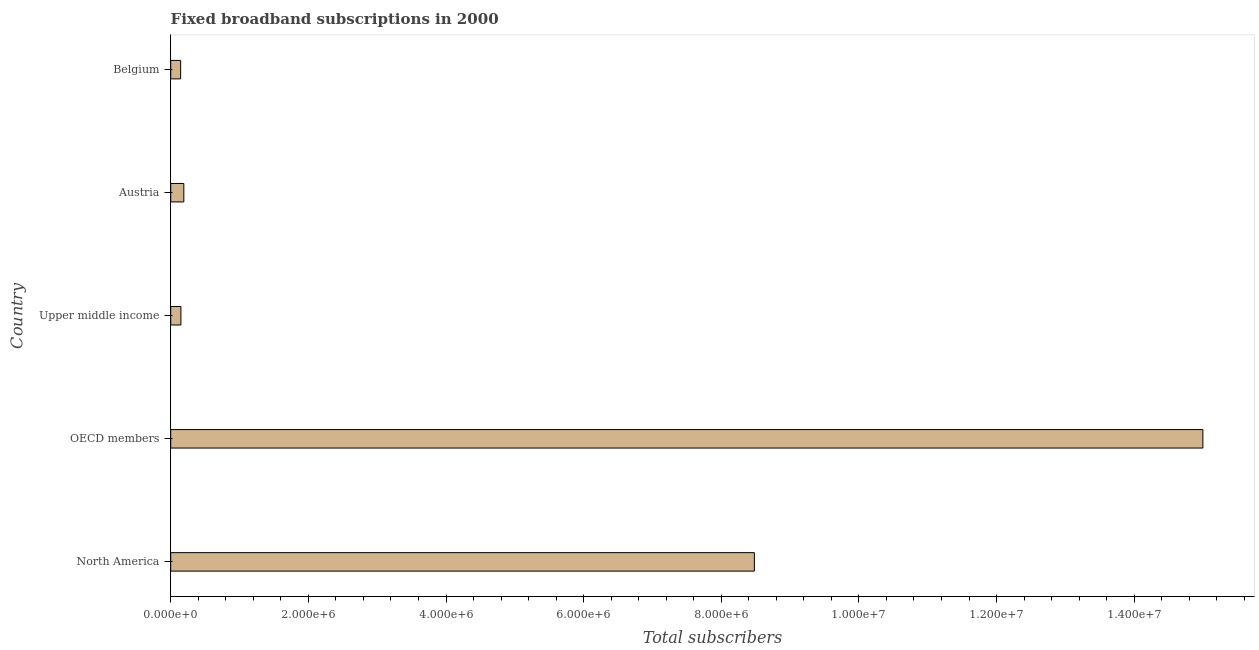What is the title of the graph?
Your response must be concise. Fixed broadband subscriptions in 2000. What is the label or title of the X-axis?
Ensure brevity in your answer.  Total subscribers. What is the label or title of the Y-axis?
Your answer should be very brief. Country. What is the total number of fixed broadband subscriptions in OECD members?
Provide a succinct answer. 1.50e+07. Across all countries, what is the maximum total number of fixed broadband subscriptions?
Keep it short and to the point. 1.50e+07. Across all countries, what is the minimum total number of fixed broadband subscriptions?
Make the answer very short. 1.44e+05. What is the sum of the total number of fixed broadband subscriptions?
Keep it short and to the point. 2.40e+07. What is the difference between the total number of fixed broadband subscriptions in Belgium and Upper middle income?
Offer a very short reply. -3828. What is the average total number of fixed broadband subscriptions per country?
Your answer should be compact. 4.79e+06. What is the median total number of fixed broadband subscriptions?
Make the answer very short. 1.90e+05. What is the difference between the highest and the second highest total number of fixed broadband subscriptions?
Offer a terse response. 6.52e+06. What is the difference between the highest and the lowest total number of fixed broadband subscriptions?
Provide a succinct answer. 1.49e+07. Are all the bars in the graph horizontal?
Keep it short and to the point. Yes. What is the difference between two consecutive major ticks on the X-axis?
Your response must be concise. 2.00e+06. What is the Total subscribers in North America?
Make the answer very short. 8.48e+06. What is the Total subscribers of OECD members?
Make the answer very short. 1.50e+07. What is the Total subscribers in Upper middle income?
Your answer should be compact. 1.48e+05. What is the Total subscribers in Austria?
Keep it short and to the point. 1.90e+05. What is the Total subscribers in Belgium?
Ensure brevity in your answer.  1.44e+05. What is the difference between the Total subscribers in North America and OECD members?
Make the answer very short. -6.52e+06. What is the difference between the Total subscribers in North America and Upper middle income?
Your response must be concise. 8.33e+06. What is the difference between the Total subscribers in North America and Austria?
Make the answer very short. 8.29e+06. What is the difference between the Total subscribers in North America and Belgium?
Keep it short and to the point. 8.34e+06. What is the difference between the Total subscribers in OECD members and Upper middle income?
Provide a short and direct response. 1.48e+07. What is the difference between the Total subscribers in OECD members and Austria?
Your answer should be very brief. 1.48e+07. What is the difference between the Total subscribers in OECD members and Belgium?
Keep it short and to the point. 1.49e+07. What is the difference between the Total subscribers in Upper middle income and Austria?
Provide a short and direct response. -4.25e+04. What is the difference between the Total subscribers in Upper middle income and Belgium?
Your answer should be very brief. 3828. What is the difference between the Total subscribers in Austria and Belgium?
Ensure brevity in your answer.  4.63e+04. What is the ratio of the Total subscribers in North America to that in OECD members?
Keep it short and to the point. 0.56. What is the ratio of the Total subscribers in North America to that in Upper middle income?
Provide a succinct answer. 57.29. What is the ratio of the Total subscribers in North America to that in Austria?
Your answer should be compact. 44.52. What is the ratio of the Total subscribers in North America to that in Belgium?
Ensure brevity in your answer.  58.81. What is the ratio of the Total subscribers in OECD members to that in Upper middle income?
Provide a short and direct response. 101.31. What is the ratio of the Total subscribers in OECD members to that in Austria?
Your response must be concise. 78.73. What is the ratio of the Total subscribers in OECD members to that in Belgium?
Give a very brief answer. 104. What is the ratio of the Total subscribers in Upper middle income to that in Austria?
Your response must be concise. 0.78. What is the ratio of the Total subscribers in Austria to that in Belgium?
Keep it short and to the point. 1.32. 